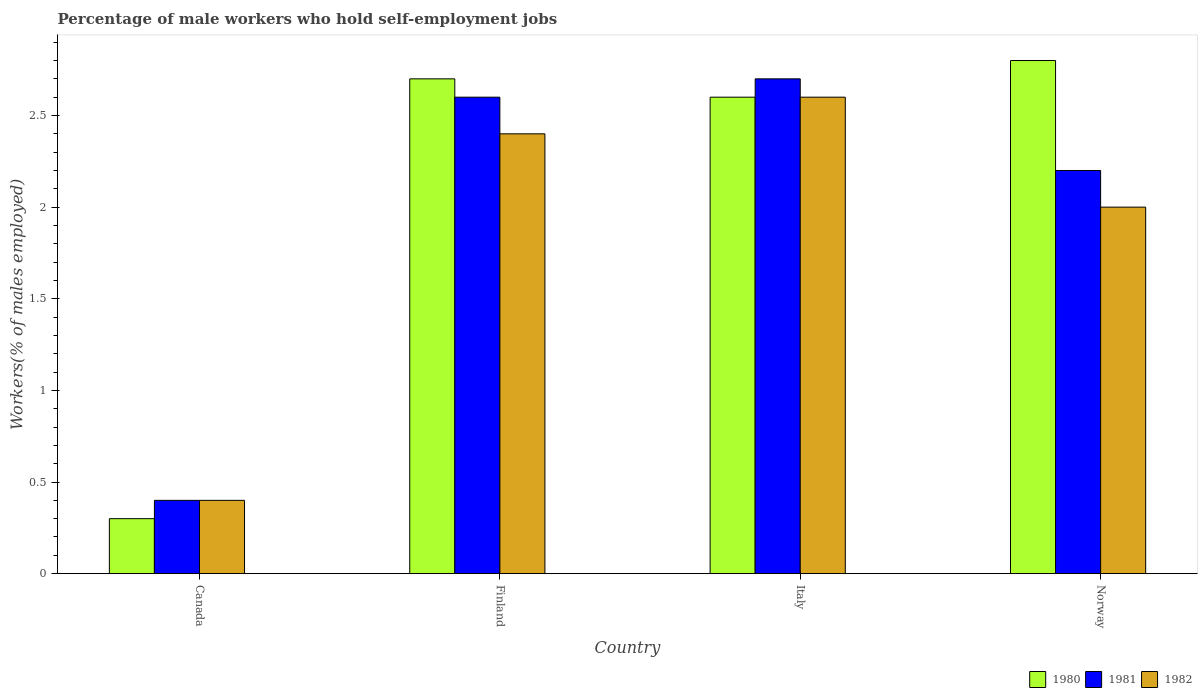How many different coloured bars are there?
Your answer should be very brief. 3. Are the number of bars on each tick of the X-axis equal?
Give a very brief answer. Yes. How many bars are there on the 3rd tick from the left?
Your response must be concise. 3. What is the percentage of self-employed male workers in 1982 in Italy?
Your response must be concise. 2.6. Across all countries, what is the maximum percentage of self-employed male workers in 1980?
Your answer should be very brief. 2.8. Across all countries, what is the minimum percentage of self-employed male workers in 1981?
Your answer should be compact. 0.4. In which country was the percentage of self-employed male workers in 1980 maximum?
Keep it short and to the point. Norway. What is the total percentage of self-employed male workers in 1982 in the graph?
Your answer should be compact. 7.4. What is the difference between the percentage of self-employed male workers in 1982 in Canada and that in Norway?
Provide a short and direct response. -1.6. What is the difference between the percentage of self-employed male workers in 1980 in Norway and the percentage of self-employed male workers in 1981 in Finland?
Provide a short and direct response. 0.2. What is the average percentage of self-employed male workers in 1981 per country?
Ensure brevity in your answer.  1.98. What is the difference between the percentage of self-employed male workers of/in 1980 and percentage of self-employed male workers of/in 1981 in Italy?
Offer a terse response. -0.1. In how many countries, is the percentage of self-employed male workers in 1980 greater than 0.30000000000000004 %?
Ensure brevity in your answer.  4. What is the ratio of the percentage of self-employed male workers in 1982 in Italy to that in Norway?
Your response must be concise. 1.3. Is the difference between the percentage of self-employed male workers in 1980 in Italy and Norway greater than the difference between the percentage of self-employed male workers in 1981 in Italy and Norway?
Provide a succinct answer. No. What is the difference between the highest and the second highest percentage of self-employed male workers in 1982?
Keep it short and to the point. -0.6. What is the difference between the highest and the lowest percentage of self-employed male workers in 1981?
Ensure brevity in your answer.  2.3. What does the 2nd bar from the left in Finland represents?
Your answer should be compact. 1981. Are all the bars in the graph horizontal?
Your response must be concise. No. How many countries are there in the graph?
Your answer should be compact. 4. What is the difference between two consecutive major ticks on the Y-axis?
Provide a short and direct response. 0.5. Are the values on the major ticks of Y-axis written in scientific E-notation?
Offer a terse response. No. Where does the legend appear in the graph?
Ensure brevity in your answer.  Bottom right. What is the title of the graph?
Your answer should be very brief. Percentage of male workers who hold self-employment jobs. What is the label or title of the Y-axis?
Your answer should be compact. Workers(% of males employed). What is the Workers(% of males employed) of 1980 in Canada?
Your answer should be very brief. 0.3. What is the Workers(% of males employed) in 1981 in Canada?
Ensure brevity in your answer.  0.4. What is the Workers(% of males employed) in 1982 in Canada?
Provide a short and direct response. 0.4. What is the Workers(% of males employed) of 1980 in Finland?
Offer a terse response. 2.7. What is the Workers(% of males employed) of 1981 in Finland?
Your answer should be very brief. 2.6. What is the Workers(% of males employed) of 1982 in Finland?
Offer a very short reply. 2.4. What is the Workers(% of males employed) in 1980 in Italy?
Give a very brief answer. 2.6. What is the Workers(% of males employed) of 1981 in Italy?
Offer a terse response. 2.7. What is the Workers(% of males employed) of 1982 in Italy?
Ensure brevity in your answer.  2.6. What is the Workers(% of males employed) of 1980 in Norway?
Make the answer very short. 2.8. What is the Workers(% of males employed) of 1981 in Norway?
Provide a short and direct response. 2.2. What is the Workers(% of males employed) of 1982 in Norway?
Give a very brief answer. 2. Across all countries, what is the maximum Workers(% of males employed) of 1980?
Keep it short and to the point. 2.8. Across all countries, what is the maximum Workers(% of males employed) of 1981?
Provide a succinct answer. 2.7. Across all countries, what is the maximum Workers(% of males employed) of 1982?
Make the answer very short. 2.6. Across all countries, what is the minimum Workers(% of males employed) in 1980?
Keep it short and to the point. 0.3. Across all countries, what is the minimum Workers(% of males employed) in 1981?
Give a very brief answer. 0.4. Across all countries, what is the minimum Workers(% of males employed) of 1982?
Your answer should be very brief. 0.4. What is the total Workers(% of males employed) in 1980 in the graph?
Offer a terse response. 8.4. What is the total Workers(% of males employed) of 1981 in the graph?
Ensure brevity in your answer.  7.9. What is the difference between the Workers(% of males employed) of 1980 in Canada and that in Finland?
Your response must be concise. -2.4. What is the difference between the Workers(% of males employed) of 1981 in Canada and that in Italy?
Your answer should be compact. -2.3. What is the difference between the Workers(% of males employed) in 1982 in Canada and that in Italy?
Your answer should be compact. -2.2. What is the difference between the Workers(% of males employed) of 1982 in Canada and that in Norway?
Your response must be concise. -1.6. What is the difference between the Workers(% of males employed) in 1980 in Finland and that in Norway?
Give a very brief answer. -0.1. What is the difference between the Workers(% of males employed) in 1982 in Finland and that in Norway?
Provide a short and direct response. 0.4. What is the difference between the Workers(% of males employed) in 1980 in Italy and that in Norway?
Offer a very short reply. -0.2. What is the difference between the Workers(% of males employed) in 1982 in Italy and that in Norway?
Make the answer very short. 0.6. What is the difference between the Workers(% of males employed) in 1980 in Canada and the Workers(% of males employed) in 1981 in Finland?
Provide a succinct answer. -2.3. What is the difference between the Workers(% of males employed) of 1980 in Canada and the Workers(% of males employed) of 1982 in Finland?
Your response must be concise. -2.1. What is the difference between the Workers(% of males employed) in 1981 in Canada and the Workers(% of males employed) in 1982 in Finland?
Give a very brief answer. -2. What is the difference between the Workers(% of males employed) of 1980 in Canada and the Workers(% of males employed) of 1981 in Italy?
Your answer should be compact. -2.4. What is the difference between the Workers(% of males employed) in 1981 in Canada and the Workers(% of males employed) in 1982 in Italy?
Offer a very short reply. -2.2. What is the difference between the Workers(% of males employed) of 1980 in Canada and the Workers(% of males employed) of 1981 in Norway?
Your answer should be very brief. -1.9. What is the difference between the Workers(% of males employed) of 1980 in Canada and the Workers(% of males employed) of 1982 in Norway?
Make the answer very short. -1.7. What is the difference between the Workers(% of males employed) of 1980 in Finland and the Workers(% of males employed) of 1981 in Italy?
Your answer should be very brief. 0. What is the difference between the Workers(% of males employed) in 1980 in Finland and the Workers(% of males employed) in 1982 in Norway?
Your response must be concise. 0.7. What is the difference between the Workers(% of males employed) of 1980 in Italy and the Workers(% of males employed) of 1982 in Norway?
Provide a succinct answer. 0.6. What is the average Workers(% of males employed) of 1980 per country?
Make the answer very short. 2.1. What is the average Workers(% of males employed) in 1981 per country?
Your answer should be compact. 1.98. What is the average Workers(% of males employed) in 1982 per country?
Offer a very short reply. 1.85. What is the difference between the Workers(% of males employed) of 1980 and Workers(% of males employed) of 1981 in Canada?
Offer a very short reply. -0.1. What is the difference between the Workers(% of males employed) of 1980 and Workers(% of males employed) of 1982 in Canada?
Offer a terse response. -0.1. What is the difference between the Workers(% of males employed) in 1980 and Workers(% of males employed) in 1981 in Finland?
Keep it short and to the point. 0.1. What is the difference between the Workers(% of males employed) in 1981 and Workers(% of males employed) in 1982 in Norway?
Ensure brevity in your answer.  0.2. What is the ratio of the Workers(% of males employed) of 1980 in Canada to that in Finland?
Offer a terse response. 0.11. What is the ratio of the Workers(% of males employed) in 1981 in Canada to that in Finland?
Give a very brief answer. 0.15. What is the ratio of the Workers(% of males employed) of 1980 in Canada to that in Italy?
Provide a succinct answer. 0.12. What is the ratio of the Workers(% of males employed) in 1981 in Canada to that in Italy?
Keep it short and to the point. 0.15. What is the ratio of the Workers(% of males employed) in 1982 in Canada to that in Italy?
Offer a terse response. 0.15. What is the ratio of the Workers(% of males employed) of 1980 in Canada to that in Norway?
Your answer should be compact. 0.11. What is the ratio of the Workers(% of males employed) in 1981 in Canada to that in Norway?
Offer a very short reply. 0.18. What is the ratio of the Workers(% of males employed) of 1982 in Finland to that in Italy?
Offer a very short reply. 0.92. What is the ratio of the Workers(% of males employed) of 1980 in Finland to that in Norway?
Offer a terse response. 0.96. What is the ratio of the Workers(% of males employed) of 1981 in Finland to that in Norway?
Your response must be concise. 1.18. What is the ratio of the Workers(% of males employed) of 1982 in Finland to that in Norway?
Your answer should be very brief. 1.2. What is the ratio of the Workers(% of males employed) of 1981 in Italy to that in Norway?
Give a very brief answer. 1.23. What is the ratio of the Workers(% of males employed) in 1982 in Italy to that in Norway?
Your answer should be compact. 1.3. What is the difference between the highest and the second highest Workers(% of males employed) in 1980?
Offer a very short reply. 0.1. What is the difference between the highest and the second highest Workers(% of males employed) of 1982?
Your answer should be compact. 0.2. What is the difference between the highest and the lowest Workers(% of males employed) of 1980?
Give a very brief answer. 2.5. What is the difference between the highest and the lowest Workers(% of males employed) of 1981?
Your response must be concise. 2.3. What is the difference between the highest and the lowest Workers(% of males employed) of 1982?
Provide a succinct answer. 2.2. 